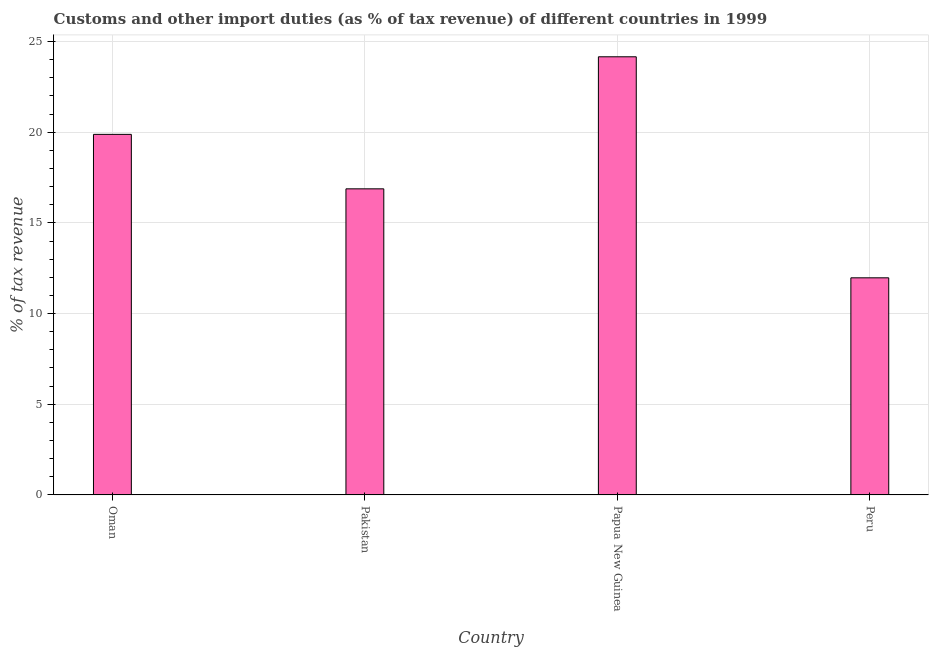What is the title of the graph?
Your answer should be compact. Customs and other import duties (as % of tax revenue) of different countries in 1999. What is the label or title of the Y-axis?
Your answer should be very brief. % of tax revenue. What is the customs and other import duties in Peru?
Give a very brief answer. 11.97. Across all countries, what is the maximum customs and other import duties?
Offer a very short reply. 24.16. Across all countries, what is the minimum customs and other import duties?
Your response must be concise. 11.97. In which country was the customs and other import duties maximum?
Offer a terse response. Papua New Guinea. In which country was the customs and other import duties minimum?
Make the answer very short. Peru. What is the sum of the customs and other import duties?
Provide a short and direct response. 72.89. What is the difference between the customs and other import duties in Papua New Guinea and Peru?
Your answer should be compact. 12.19. What is the average customs and other import duties per country?
Keep it short and to the point. 18.22. What is the median customs and other import duties?
Offer a very short reply. 18.38. In how many countries, is the customs and other import duties greater than 1 %?
Your response must be concise. 4. What is the ratio of the customs and other import duties in Oman to that in Peru?
Provide a short and direct response. 1.66. What is the difference between the highest and the second highest customs and other import duties?
Offer a terse response. 4.28. Is the sum of the customs and other import duties in Papua New Guinea and Peru greater than the maximum customs and other import duties across all countries?
Offer a very short reply. Yes. What is the difference between the highest and the lowest customs and other import duties?
Your answer should be very brief. 12.19. In how many countries, is the customs and other import duties greater than the average customs and other import duties taken over all countries?
Your answer should be compact. 2. Are all the bars in the graph horizontal?
Give a very brief answer. No. How many countries are there in the graph?
Offer a terse response. 4. Are the values on the major ticks of Y-axis written in scientific E-notation?
Make the answer very short. No. What is the % of tax revenue of Oman?
Offer a terse response. 19.88. What is the % of tax revenue of Pakistan?
Give a very brief answer. 16.88. What is the % of tax revenue of Papua New Guinea?
Your response must be concise. 24.16. What is the % of tax revenue of Peru?
Provide a short and direct response. 11.97. What is the difference between the % of tax revenue in Oman and Pakistan?
Provide a succinct answer. 3. What is the difference between the % of tax revenue in Oman and Papua New Guinea?
Ensure brevity in your answer.  -4.28. What is the difference between the % of tax revenue in Oman and Peru?
Your response must be concise. 7.91. What is the difference between the % of tax revenue in Pakistan and Papua New Guinea?
Make the answer very short. -7.28. What is the difference between the % of tax revenue in Pakistan and Peru?
Your answer should be compact. 4.91. What is the difference between the % of tax revenue in Papua New Guinea and Peru?
Provide a short and direct response. 12.19. What is the ratio of the % of tax revenue in Oman to that in Pakistan?
Keep it short and to the point. 1.18. What is the ratio of the % of tax revenue in Oman to that in Papua New Guinea?
Your answer should be compact. 0.82. What is the ratio of the % of tax revenue in Oman to that in Peru?
Provide a short and direct response. 1.66. What is the ratio of the % of tax revenue in Pakistan to that in Papua New Guinea?
Offer a very short reply. 0.7. What is the ratio of the % of tax revenue in Pakistan to that in Peru?
Ensure brevity in your answer.  1.41. What is the ratio of the % of tax revenue in Papua New Guinea to that in Peru?
Your response must be concise. 2.02. 